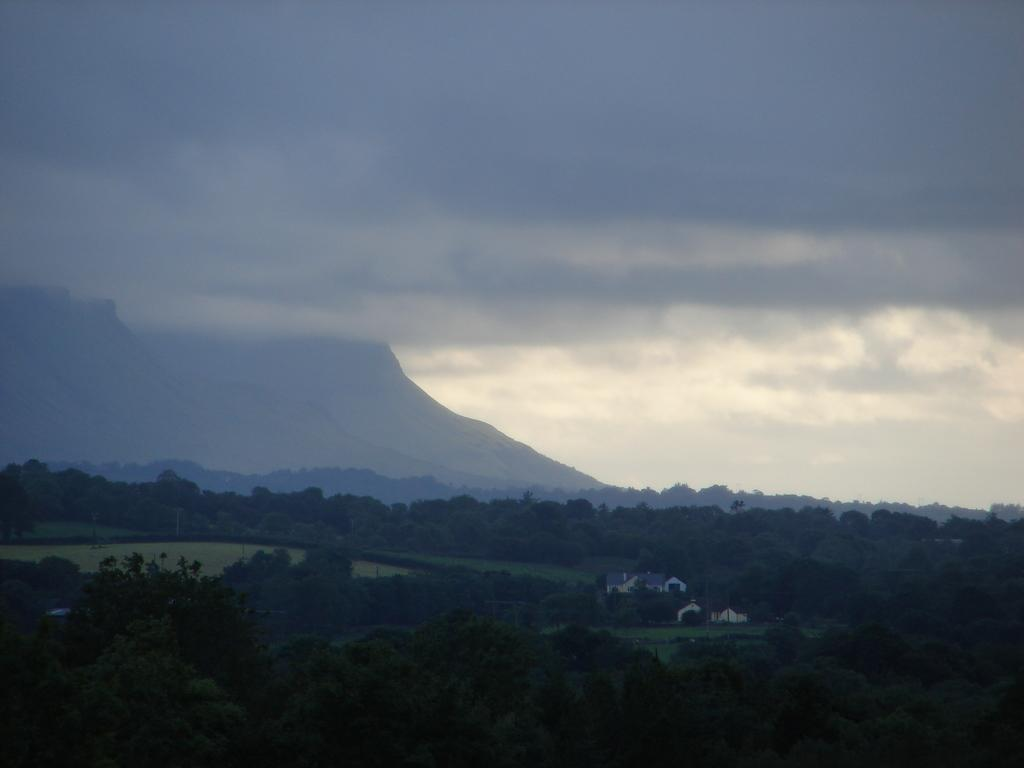What type of natural elements can be seen in the image? There are trees and mountains in the image. What type of man-made structures are present in the image? There are houses in the image. What is visible in the background of the image? The sky is visible in the image. What type of wine is being served at the picnic in the image? There is no picnic or wine present in the image; it features trees, mountains, houses, and the sky. What color is the skirt worn by the person in the image? There is no person or skirt present in the image. 